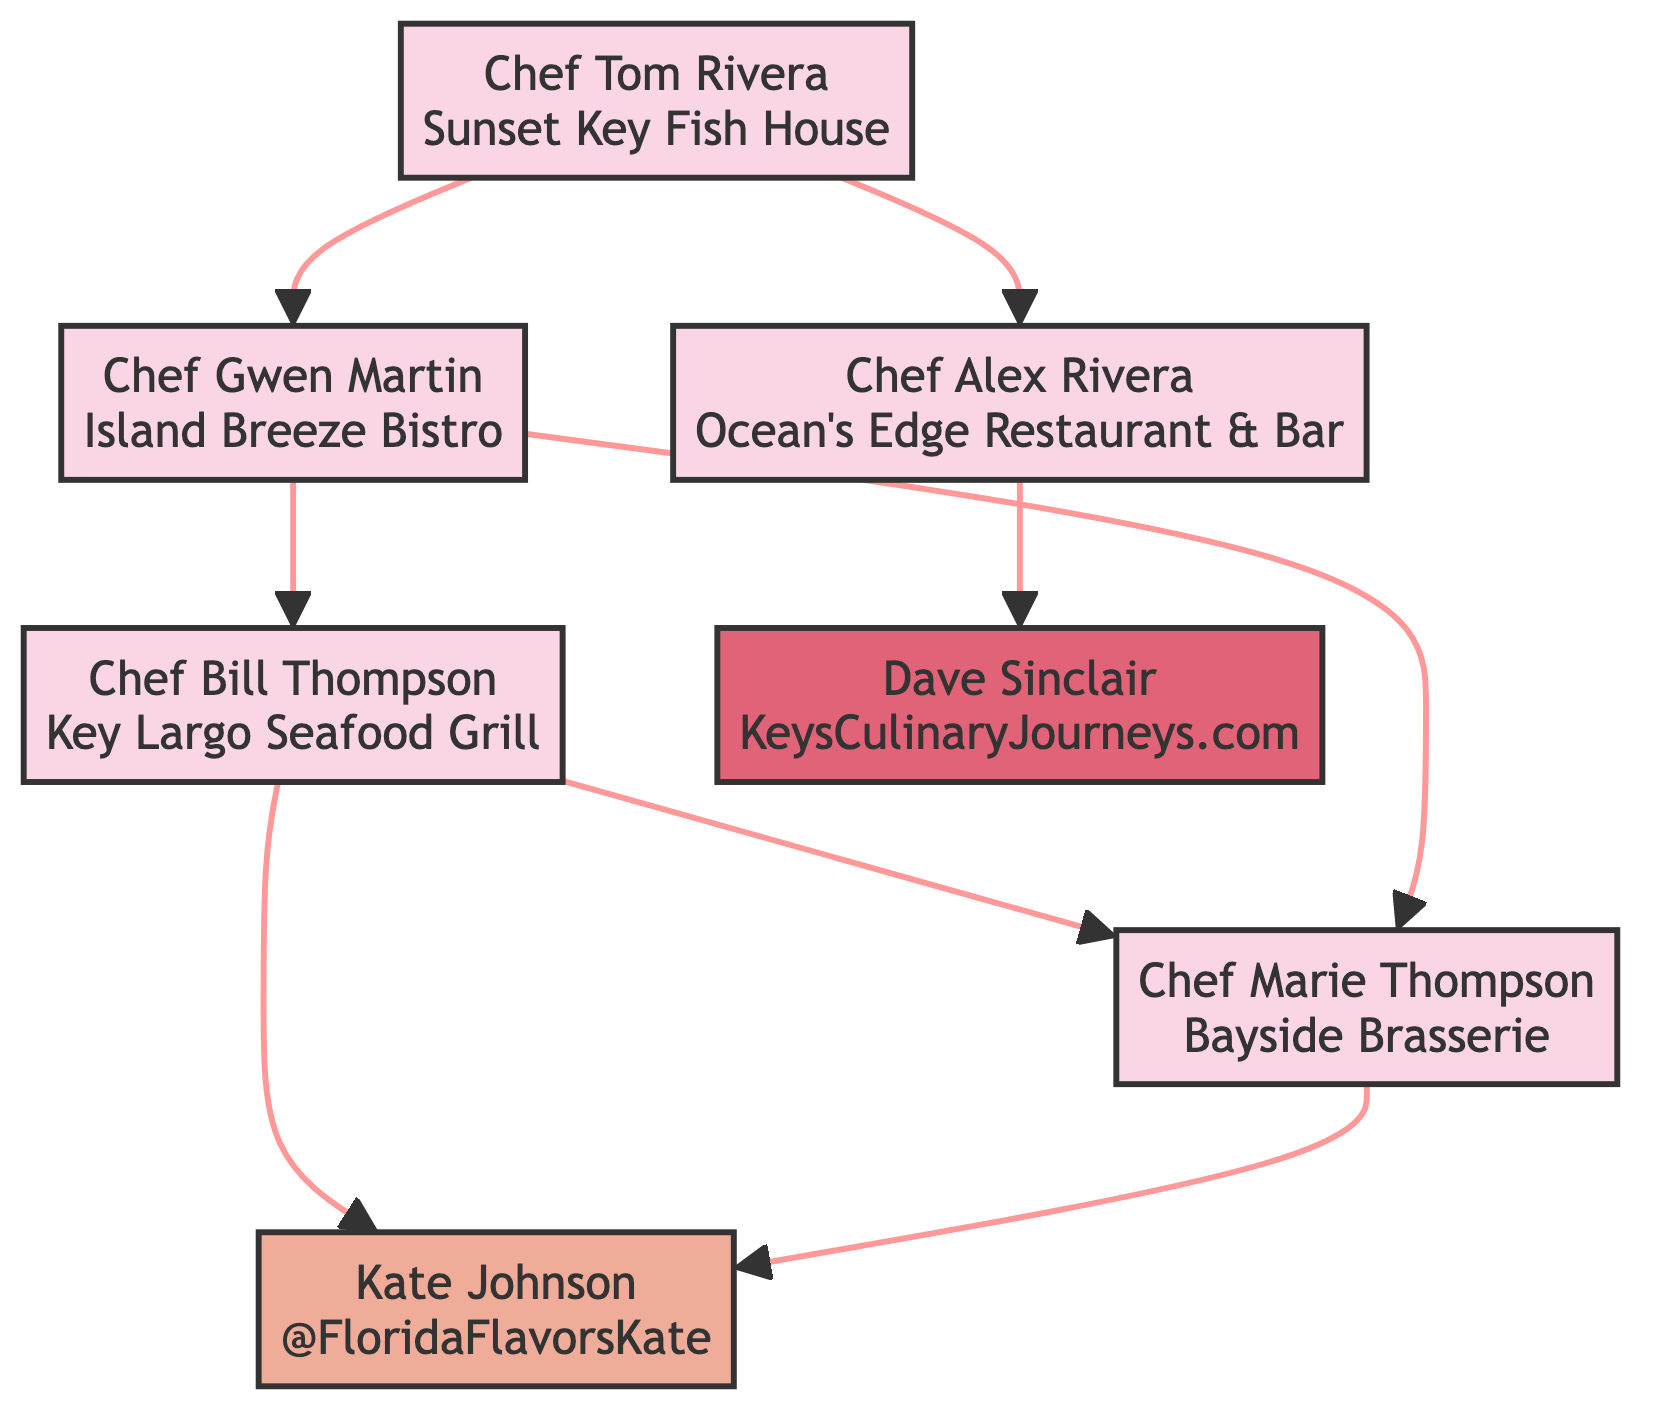What is the restaurant owned by Chef Bill Thompson? Chef Bill Thompson is connected to the node for "Key Largo Seafood Grill," which is explicitly stated as his restaurant in the diagram.
Answer: Key Largo Seafood Grill Who influences Chef Marie Thompson? The diagram shows that Chef Marie Thompson is influenced by both Chef Gwen Martin and Chef Bill Thompson, as indicated in her relationships.
Answer: Chef Gwen Martin, Chef Bill Thompson How many children does Chef Tom Rivera have? By inspecting Chef Tom Rivera's relationships in the diagram, it is clear that he has two children, listed as Chef Alex Rivera and Chef Gwen Martin.
Answer: 2 Which chef owns Island Breeze Bistro? The diagram clearly labels Chef Gwen Martin as the founder and head chef of Island Breeze Bistro, making her the owner of that restaurant.
Answer: Chef Gwen Martin Which local food influencer is influenced by both Chef Bill Thompson and Chef Marie Thompson? The relationships for Kate Johnson in the diagram indicate she is influenced by both Chef Bill Thompson and Chef Marie Thompson, as specified in her influences.
Answer: Kate Johnson What is Dave Sinclair's occupation? According to the diagram, Dave Sinclair is identified as a local food blogger, which is explicitly stated in his node.
Answer: Local Food Blogger Which chef is related as a child to Chef Tom Rivera? The diagram specifies that Chef Tom Rivera has two children: Chef Alex Rivera and Chef Gwen Martin, so either one can fit this description, but the question asks for any.
Answer: Chef Alex Rivera How many influencers are connected to the chefs in this diagram? By reviewing all the influencers listed in the relationships of the chefs, there are three unique influencers total: Kate Johnson (influenced by both Chef Bill Thompson and Chef Marie Thompson) and Dave Sinclair (influenced by Chef Alex Rivera).
Answer: 2 Who is the executive chef at Ocean's Edge Restaurant & Bar? According to the relationships in the diagram, Chef Alex Rivera is identified as the executive chef at the restaurant known as Ocean's Edge Restaurant & Bar.
Answer: Chef Alex Rivera 